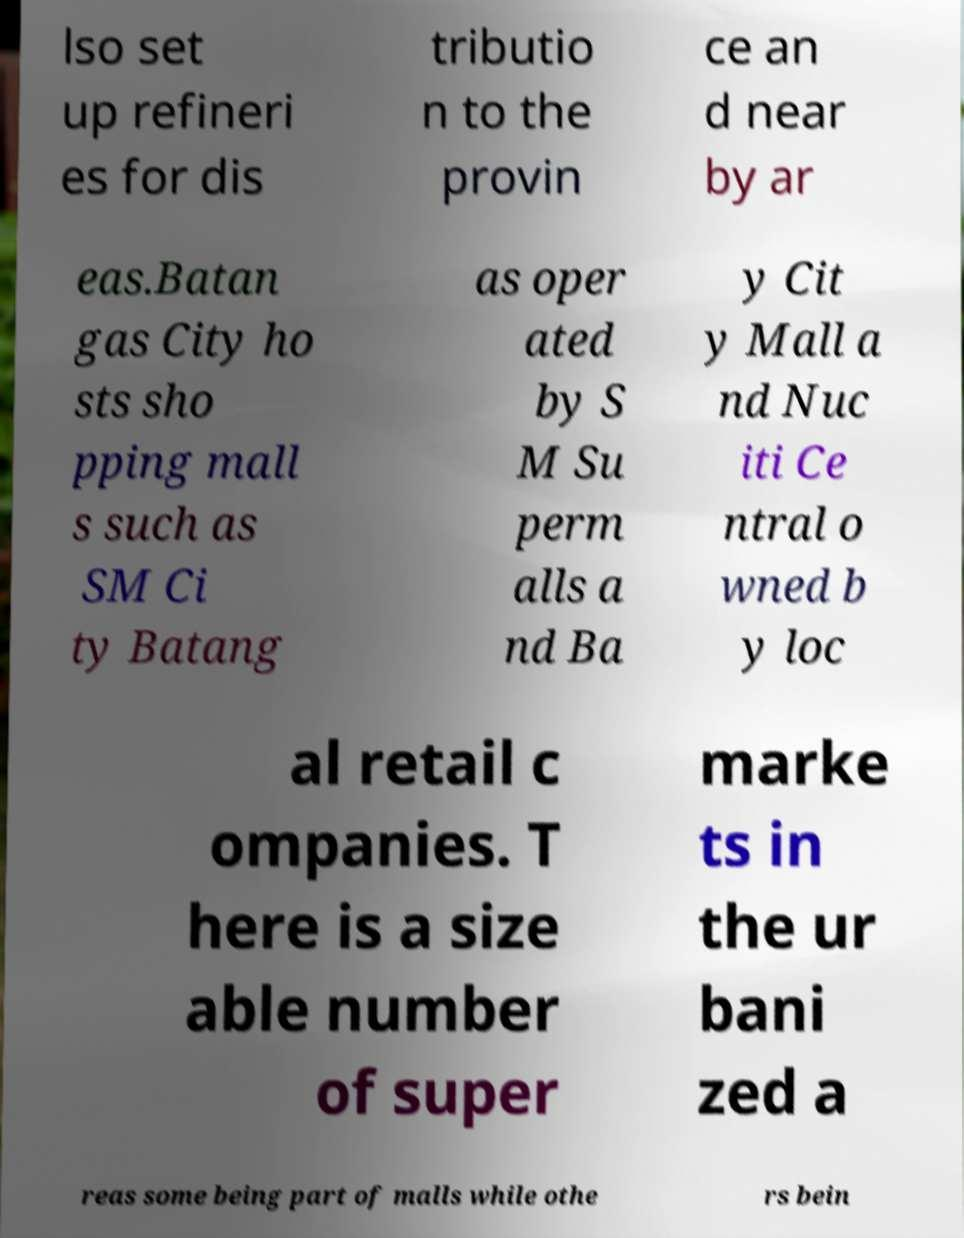Could you assist in decoding the text presented in this image and type it out clearly? lso set up refineri es for dis tributio n to the provin ce an d near by ar eas.Batan gas City ho sts sho pping mall s such as SM Ci ty Batang as oper ated by S M Su perm alls a nd Ba y Cit y Mall a nd Nuc iti Ce ntral o wned b y loc al retail c ompanies. T here is a size able number of super marke ts in the ur bani zed a reas some being part of malls while othe rs bein 